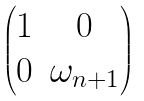<formula> <loc_0><loc_0><loc_500><loc_500>\begin{pmatrix} 1 & 0 \\ 0 & \omega _ { n + 1 } \end{pmatrix}</formula> 